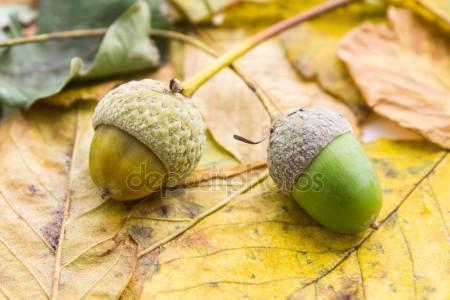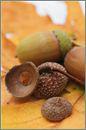The first image is the image on the left, the second image is the image on the right. Examine the images to the left and right. Is the description "The acorns in one of the images are green, while the acorns in the other image are brown." accurate? Answer yes or no. Yes. 